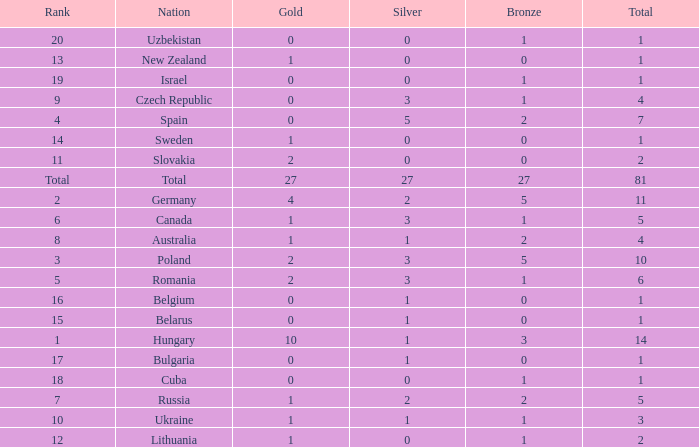Which Bronze has a Gold of 2, and a Nation of slovakia, and a Total larger than 2? None. 